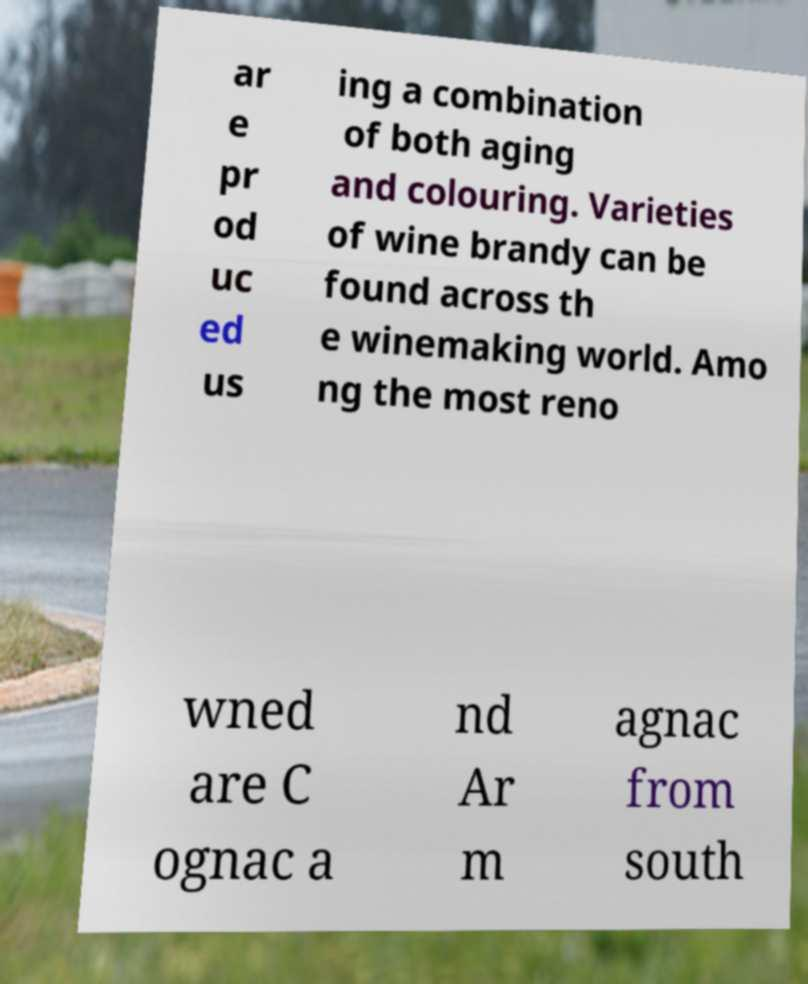Can you read and provide the text displayed in the image?This photo seems to have some interesting text. Can you extract and type it out for me? ar e pr od uc ed us ing a combination of both aging and colouring. Varieties of wine brandy can be found across th e winemaking world. Amo ng the most reno wned are C ognac a nd Ar m agnac from south 